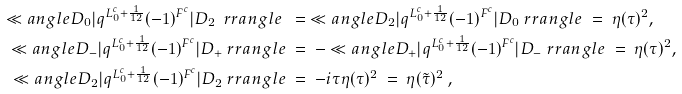Convert formula to latex. <formula><loc_0><loc_0><loc_500><loc_500>\ll a n g l e D _ { 0 } | q ^ { L _ { 0 } ^ { c } + \frac { 1 } { 1 2 } } ( - 1 ) ^ { F ^ { c } } | D _ { 2 } \ r r a n g l e \ & = \ \ll a n g l e D _ { 2 } | q ^ { L _ { 0 } ^ { c } + \frac { 1 } { 1 2 } } ( - 1 ) ^ { F ^ { c } } | D _ { 0 } \ r r a n g l e \ = \ \eta ( \tau ) ^ { 2 } , \\ \ll a n g l e D _ { - } | q ^ { L _ { 0 } ^ { c } + \frac { 1 } { 1 2 } } ( - 1 ) ^ { F ^ { c } } | D _ { + } \ r r a n g l e \ & = \ - \ll a n g l e D _ { + } | q ^ { L _ { 0 } ^ { c } + \frac { 1 } { 1 2 } } ( - 1 ) ^ { F ^ { c } } | D _ { - } \ r r a n g l e \ = \ \eta ( \tau ) ^ { 2 } , \\ \ll a n g l e D _ { 2 } | q ^ { L _ { 0 } ^ { c } + \frac { 1 } { 1 2 } } ( - 1 ) ^ { F ^ { c } } | D _ { 2 } \ r r a n g l e \ & = \ - i \tau \eta ( \tau ) ^ { 2 } \ = \ \eta ( \tilde { \tau } ) ^ { 2 } \ , \\</formula> 